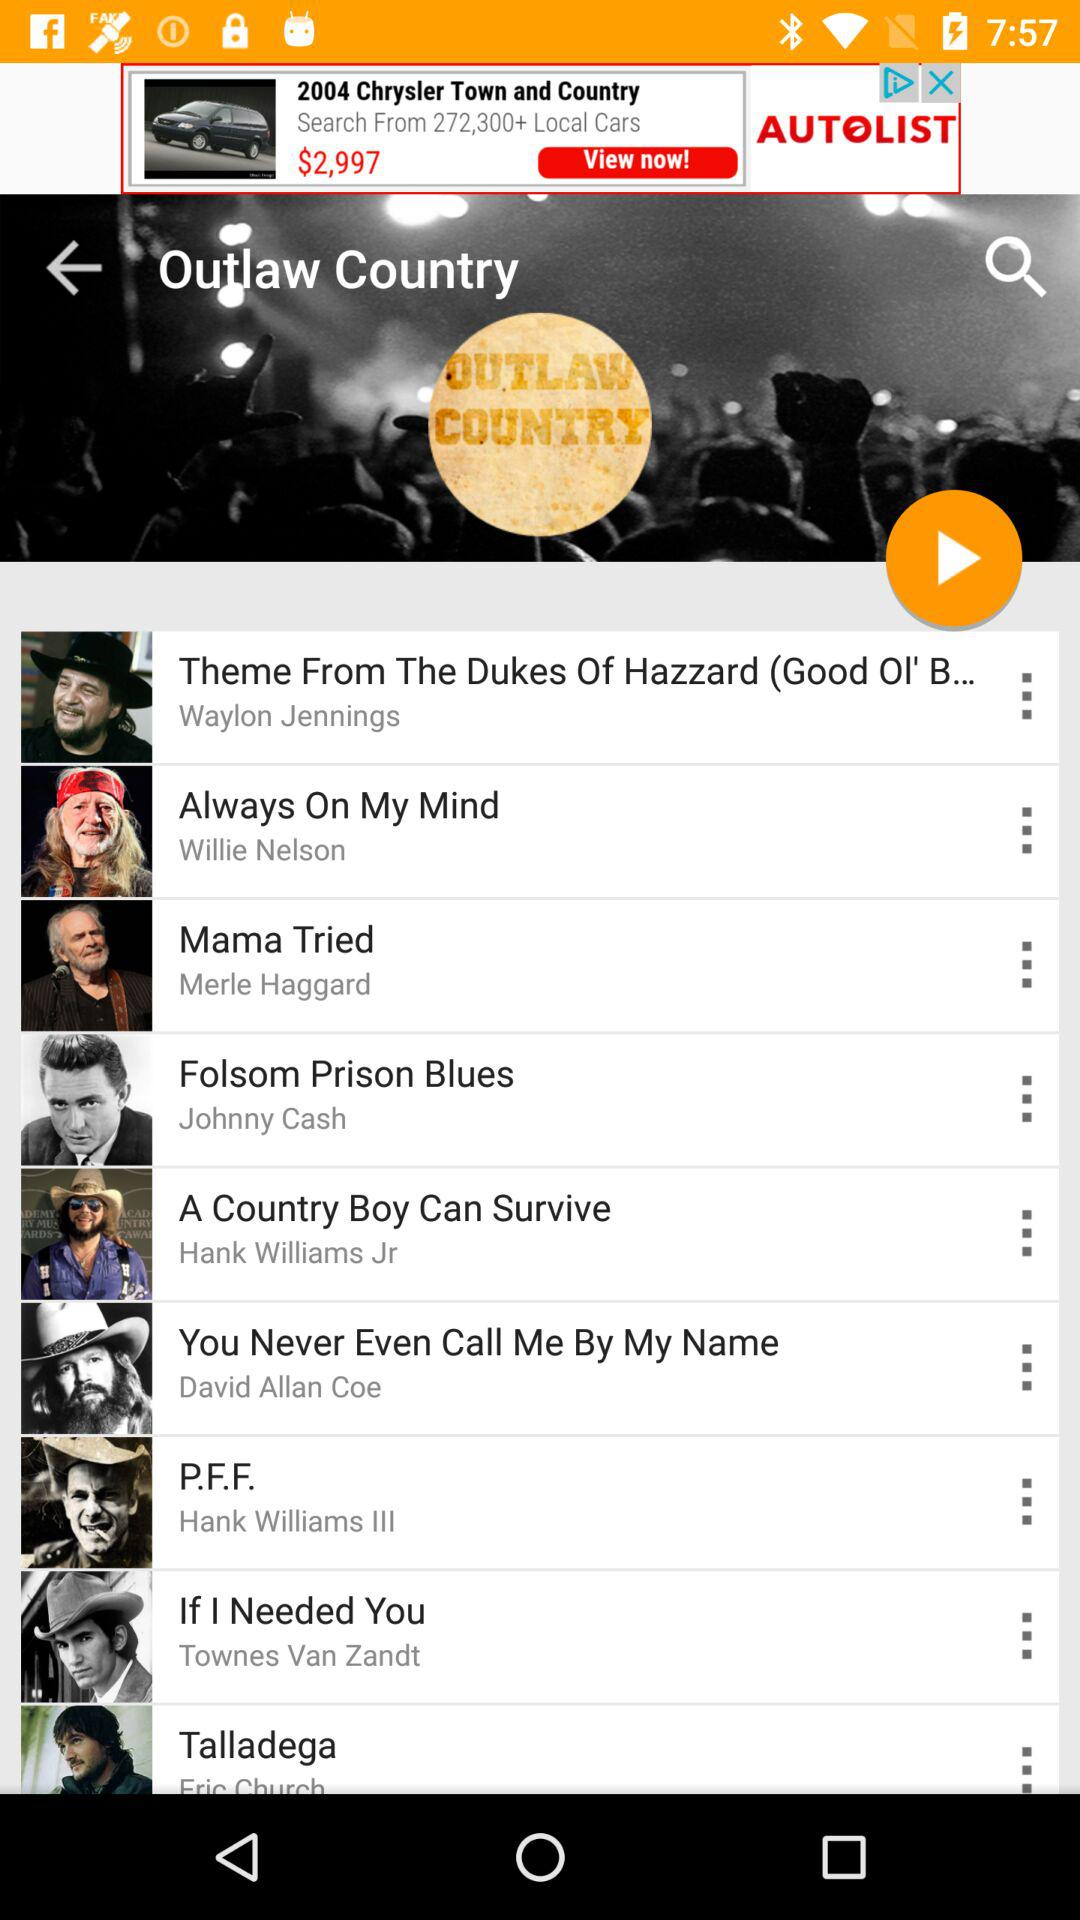Who is the singer of "Always On My Mind"? The singer of "Always On My Mind" is Willie Nelson. 